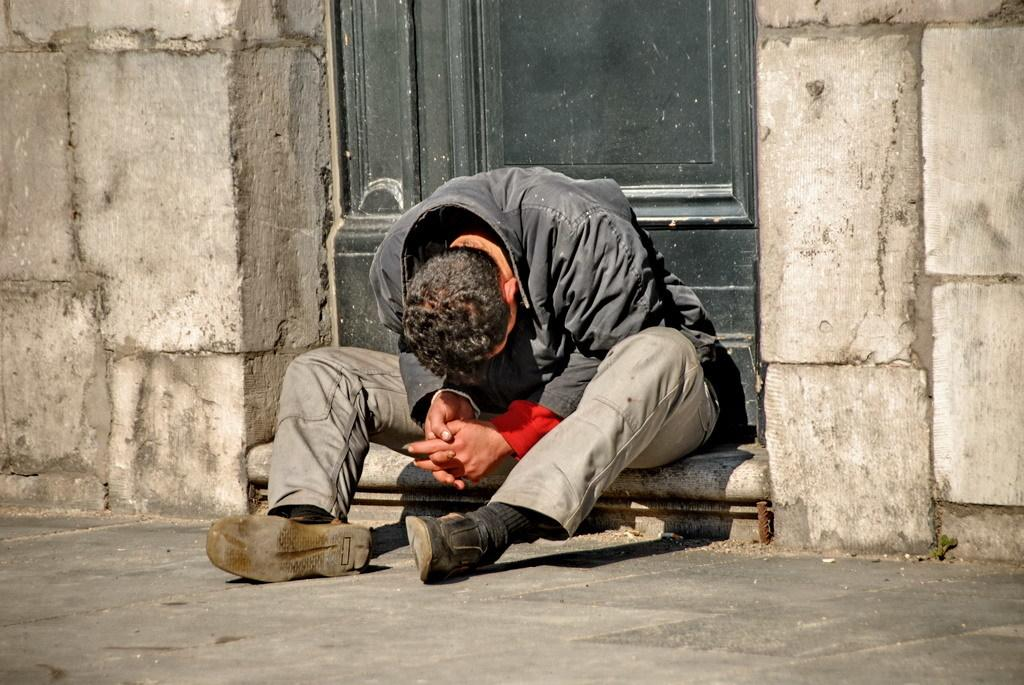What is the main subject of the image? There is a person sitting in the image. Where is the person sitting in relation to the door? The person is sitting in front of a door. What can be seen beside the door? There is a wall beside the door. What type of cloth is being used to take the picture of the person sitting in front of the door? There is no cloth or camera present in the image, so it cannot be determined if a picture is being taken. 